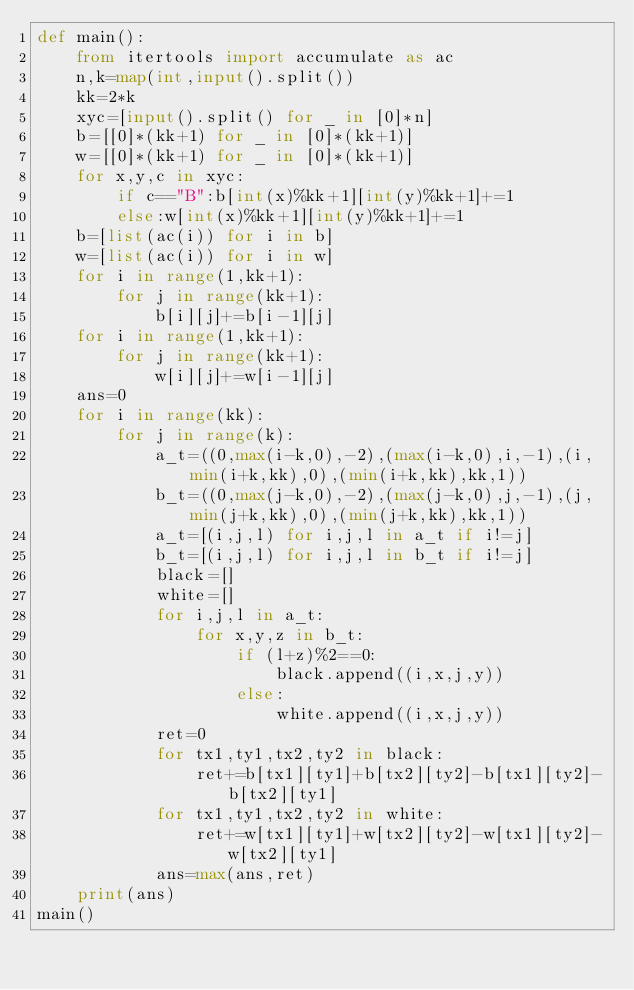<code> <loc_0><loc_0><loc_500><loc_500><_Python_>def main():
    from itertools import accumulate as ac
    n,k=map(int,input().split())
    kk=2*k
    xyc=[input().split() for _ in [0]*n]
    b=[[0]*(kk+1) for _ in [0]*(kk+1)]
    w=[[0]*(kk+1) for _ in [0]*(kk+1)]
    for x,y,c in xyc:
        if c=="B":b[int(x)%kk+1][int(y)%kk+1]+=1
        else:w[int(x)%kk+1][int(y)%kk+1]+=1
    b=[list(ac(i)) for i in b]
    w=[list(ac(i)) for i in w]
    for i in range(1,kk+1):
        for j in range(kk+1):
            b[i][j]+=b[i-1][j]
    for i in range(1,kk+1):
        for j in range(kk+1):
            w[i][j]+=w[i-1][j]
    ans=0
    for i in range(kk):
        for j in range(k):
            a_t=((0,max(i-k,0),-2),(max(i-k,0),i,-1),(i,min(i+k,kk),0),(min(i+k,kk),kk,1))
            b_t=((0,max(j-k,0),-2),(max(j-k,0),j,-1),(j,min(j+k,kk),0),(min(j+k,kk),kk,1))
            a_t=[(i,j,l) for i,j,l in a_t if i!=j]
            b_t=[(i,j,l) for i,j,l in b_t if i!=j]
            black=[]
            white=[]
            for i,j,l in a_t:
                for x,y,z in b_t:
                    if (l+z)%2==0:
                        black.append((i,x,j,y))
                    else:
                        white.append((i,x,j,y))
            ret=0
            for tx1,ty1,tx2,ty2 in black:
                ret+=b[tx1][ty1]+b[tx2][ty2]-b[tx1][ty2]-b[tx2][ty1]
            for tx1,ty1,tx2,ty2 in white:
                ret+=w[tx1][ty1]+w[tx2][ty2]-w[tx1][ty2]-w[tx2][ty1]
            ans=max(ans,ret)
    print(ans)
main()</code> 